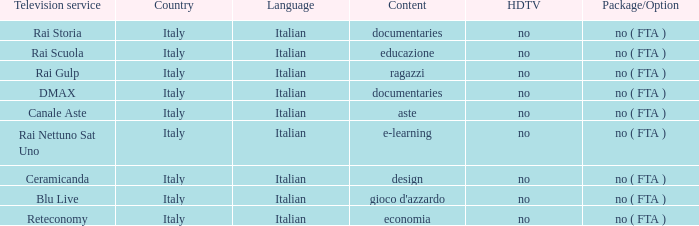What is the language when the reteconomy is the television provider? Italian. 